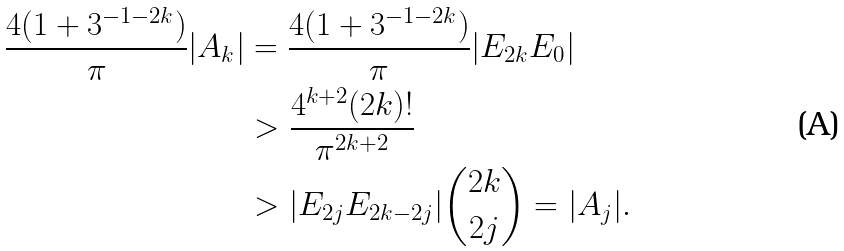Convert formula to latex. <formula><loc_0><loc_0><loc_500><loc_500>\frac { 4 ( 1 + 3 ^ { - 1 - 2 k } ) } { \pi } | A _ { k } | & = \frac { 4 ( 1 + 3 ^ { - 1 - 2 k } ) } { \pi } | E _ { 2 k } E _ { 0 } | \\ & > \frac { 4 ^ { k + 2 } ( 2 k ) ! } { \pi ^ { 2 k + 2 } } \\ & > | E _ { 2 j } E _ { 2 k - 2 j } | \binom { 2 k } { 2 j } = | A _ { j } | .</formula> 